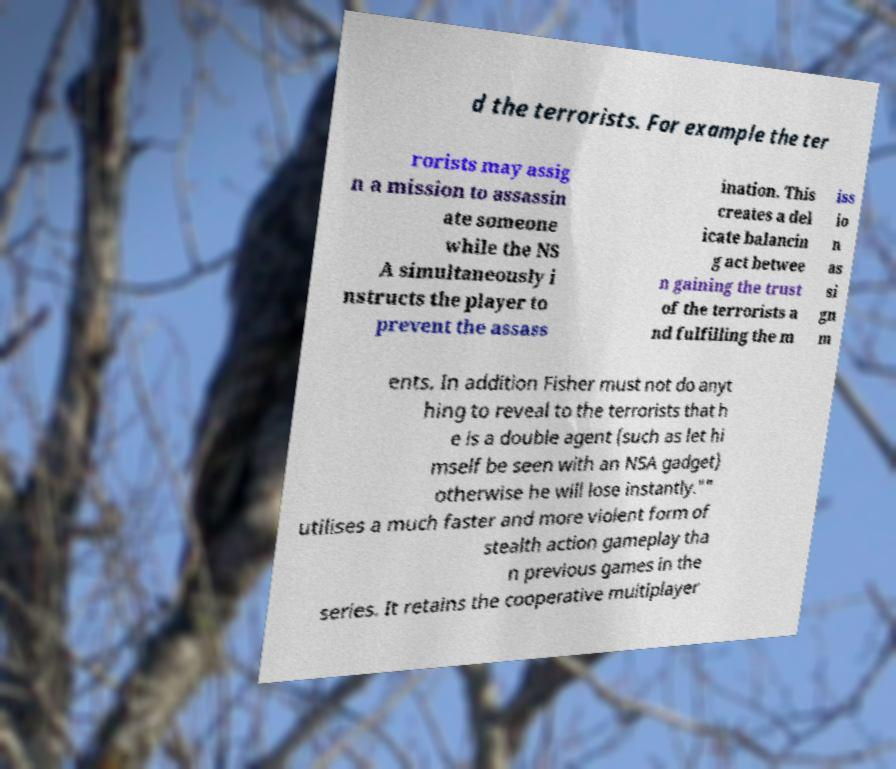I need the written content from this picture converted into text. Can you do that? d the terrorists. For example the ter rorists may assig n a mission to assassin ate someone while the NS A simultaneously i nstructs the player to prevent the assass ination. This creates a del icate balancin g act betwee n gaining the trust of the terrorists a nd fulfilling the m iss io n as si gn m ents. In addition Fisher must not do anyt hing to reveal to the terrorists that h e is a double agent (such as let hi mself be seen with an NSA gadget) otherwise he will lose instantly."" utilises a much faster and more violent form of stealth action gameplay tha n previous games in the series. It retains the cooperative multiplayer 